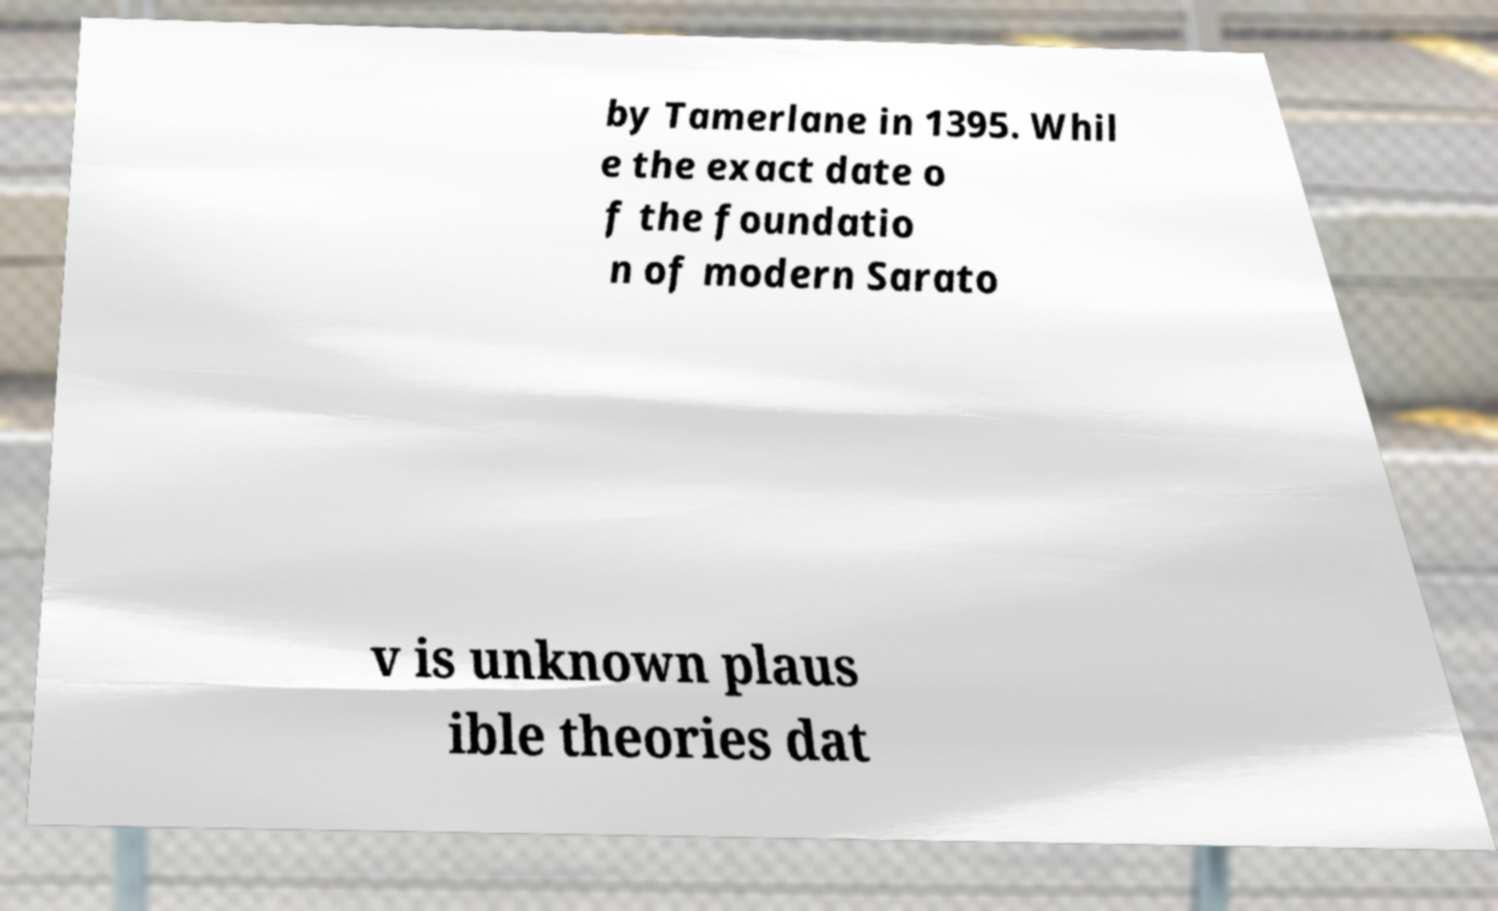Please read and relay the text visible in this image. What does it say? by Tamerlane in 1395. Whil e the exact date o f the foundatio n of modern Sarato v is unknown plaus ible theories dat 